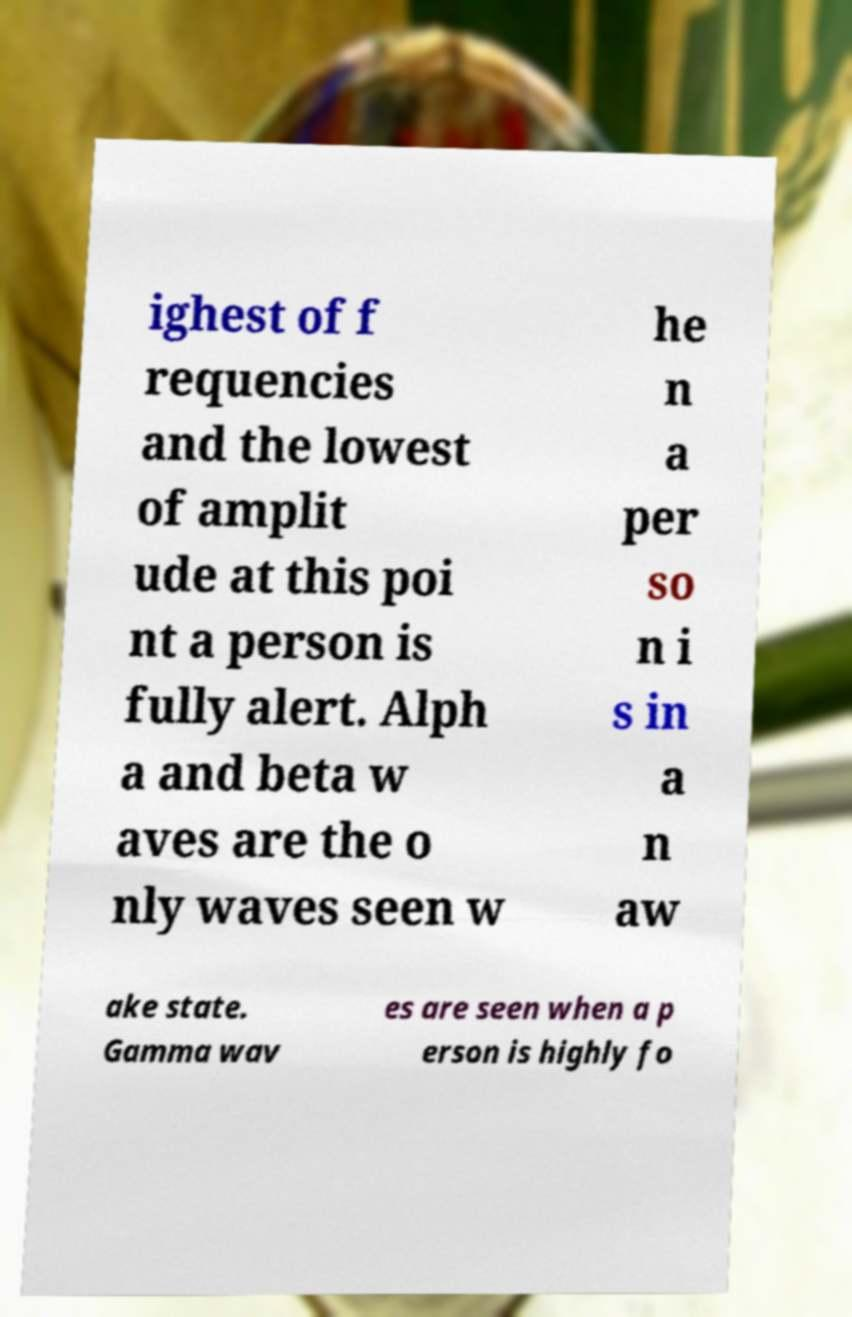Can you read and provide the text displayed in the image?This photo seems to have some interesting text. Can you extract and type it out for me? ighest of f requencies and the lowest of amplit ude at this poi nt a person is fully alert. Alph a and beta w aves are the o nly waves seen w he n a per so n i s in a n aw ake state. Gamma wav es are seen when a p erson is highly fo 